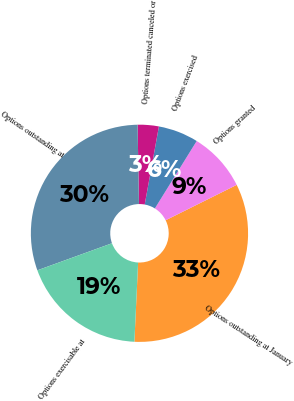<chart> <loc_0><loc_0><loc_500><loc_500><pie_chart><fcel>Options outstanding at January<fcel>Options granted<fcel>Options exercised<fcel>Options terminated canceled or<fcel>Options outstanding at<fcel>Options exercisable at<nl><fcel>33.1%<fcel>8.81%<fcel>5.97%<fcel>3.14%<fcel>30.26%<fcel>18.72%<nl></chart> 